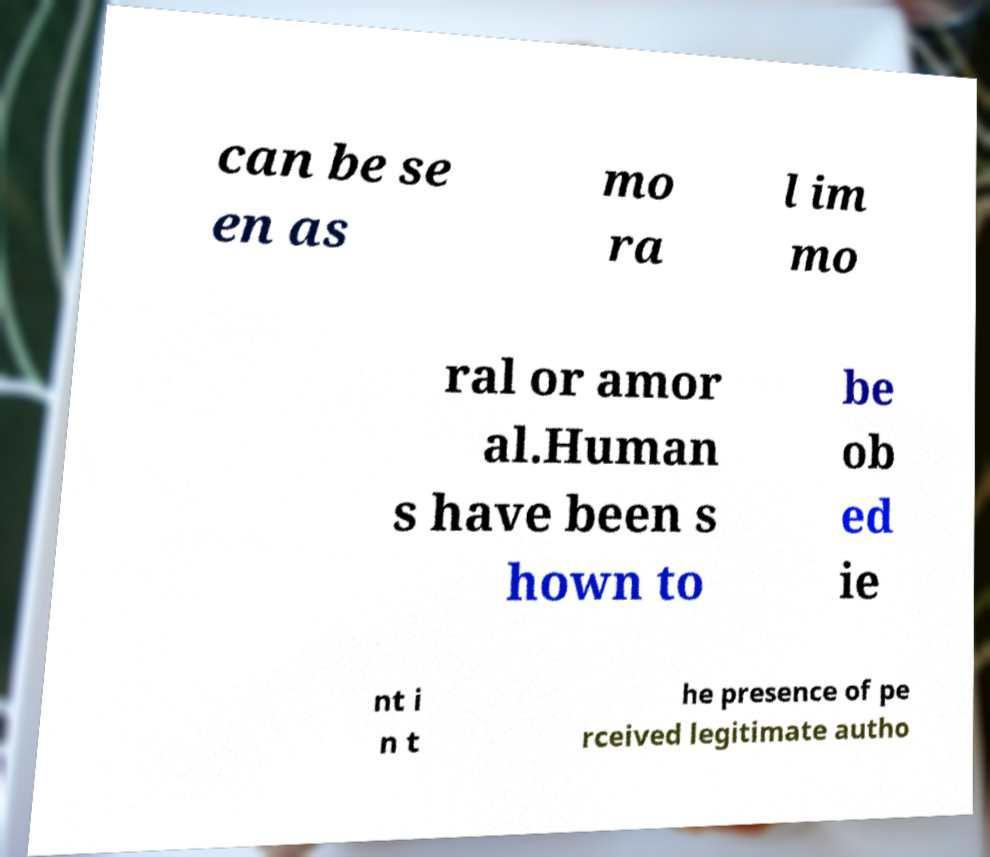Could you extract and type out the text from this image? can be se en as mo ra l im mo ral or amor al.Human s have been s hown to be ob ed ie nt i n t he presence of pe rceived legitimate autho 